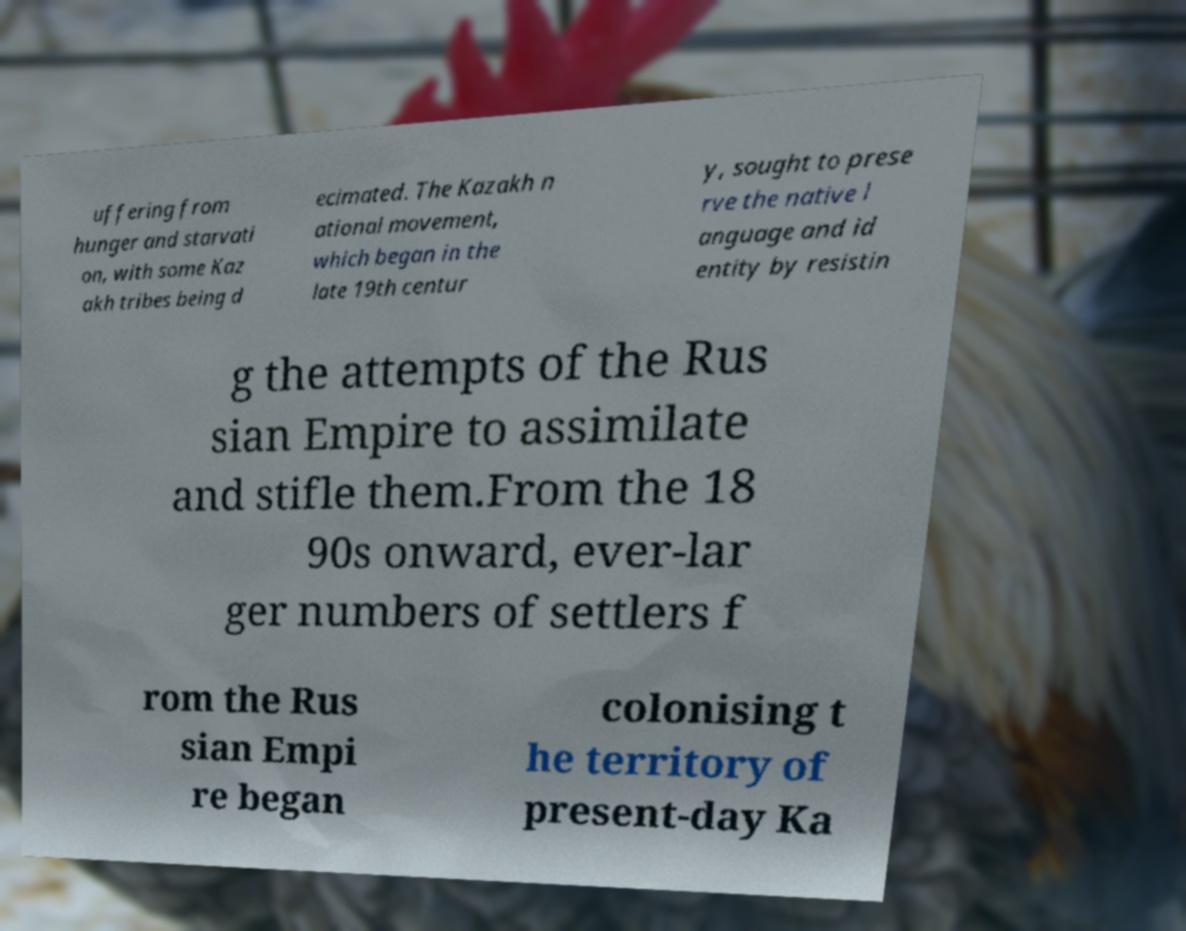Could you extract and type out the text from this image? uffering from hunger and starvati on, with some Kaz akh tribes being d ecimated. The Kazakh n ational movement, which began in the late 19th centur y, sought to prese rve the native l anguage and id entity by resistin g the attempts of the Rus sian Empire to assimilate and stifle them.From the 18 90s onward, ever-lar ger numbers of settlers f rom the Rus sian Empi re began colonising t he territory of present-day Ka 